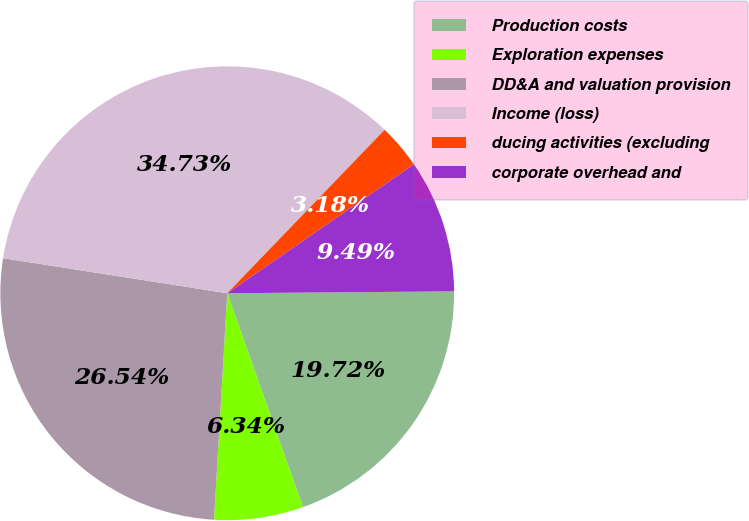<chart> <loc_0><loc_0><loc_500><loc_500><pie_chart><fcel>Production costs<fcel>Exploration expenses<fcel>DD&A and valuation provision<fcel>Income (loss)<fcel>ducing activities (excluding<fcel>corporate overhead and<nl><fcel>19.72%<fcel>6.34%<fcel>26.54%<fcel>34.73%<fcel>3.18%<fcel>9.49%<nl></chart> 